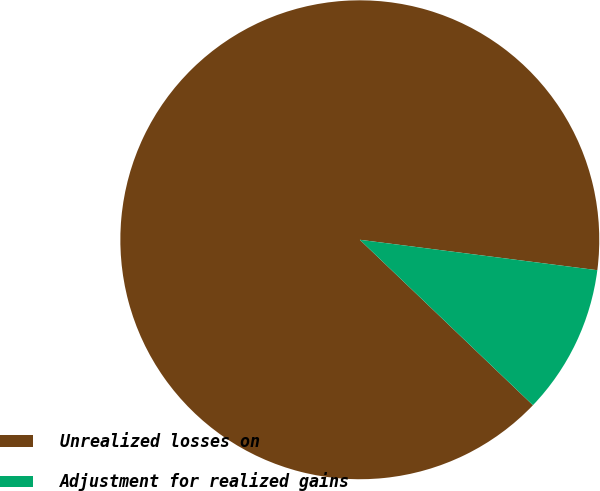Convert chart to OTSL. <chart><loc_0><loc_0><loc_500><loc_500><pie_chart><fcel>Unrealized losses on<fcel>Adjustment for realized gains<nl><fcel>89.89%<fcel>10.11%<nl></chart> 